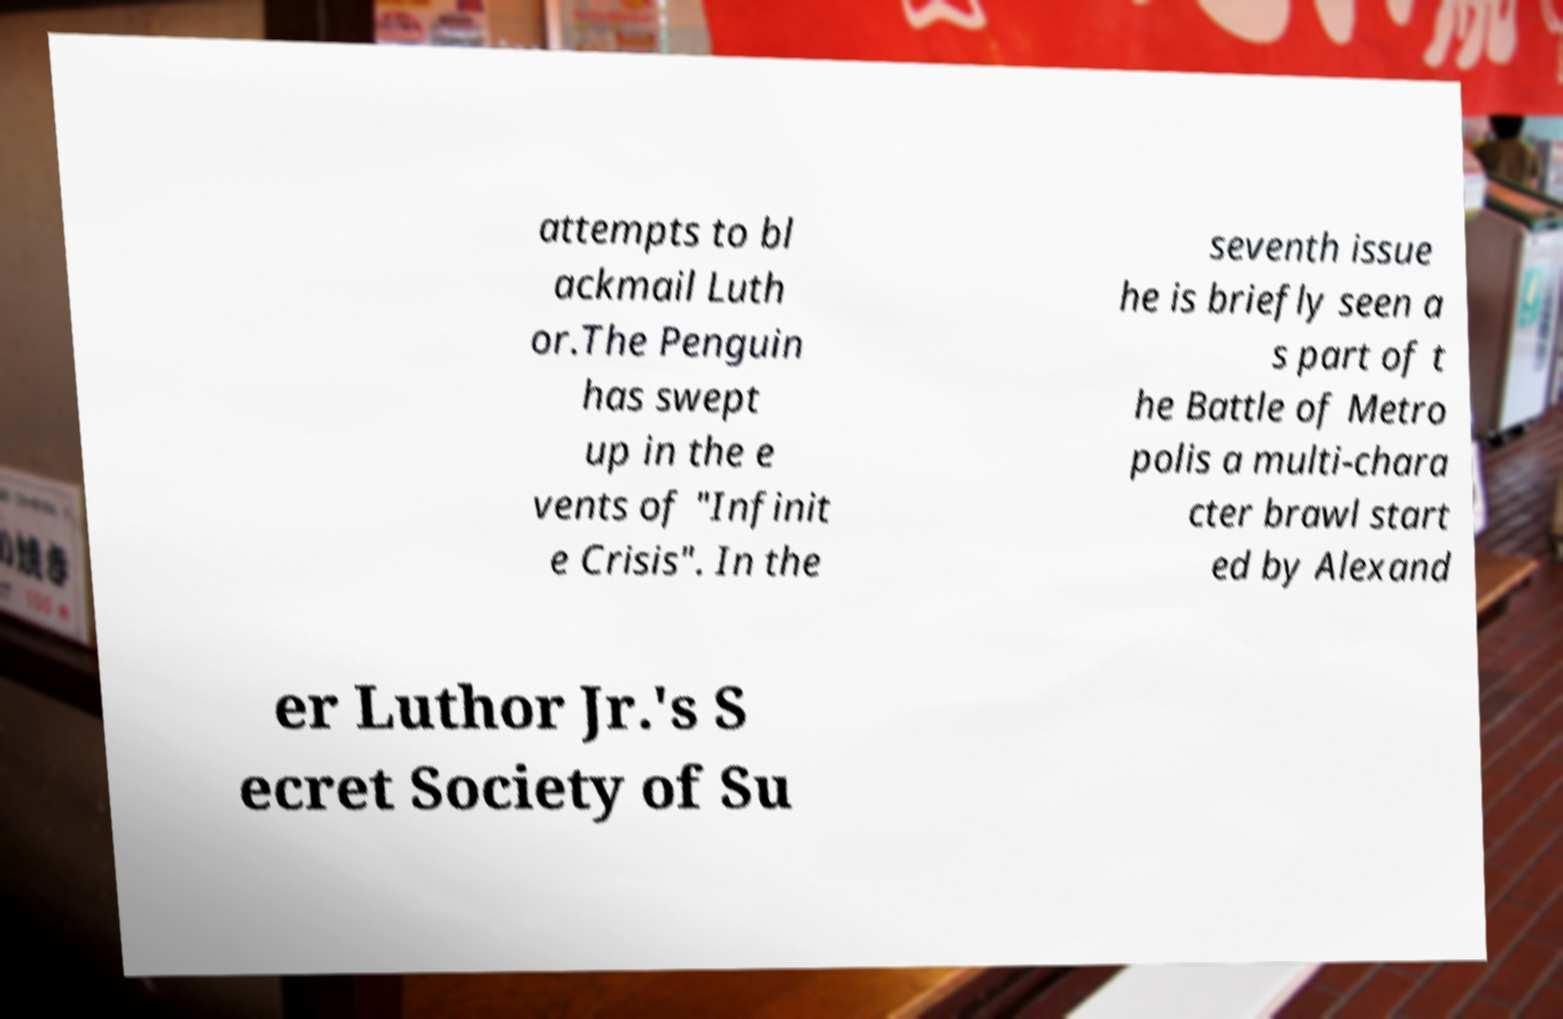Could you assist in decoding the text presented in this image and type it out clearly? attempts to bl ackmail Luth or.The Penguin has swept up in the e vents of "Infinit e Crisis". In the seventh issue he is briefly seen a s part of t he Battle of Metro polis a multi-chara cter brawl start ed by Alexand er Luthor Jr.'s S ecret Society of Su 